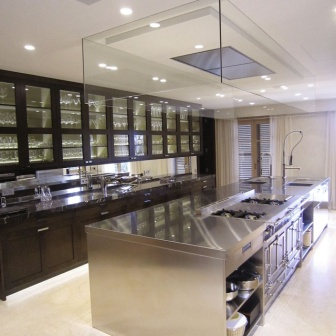Describe more details about the lighting setup in this kitchen. The lighting in this kitchen is both functional and ornamental. Ceiling-mounted rectangular fixtures distribute light evenly across the room, eliminating shadows and enhancing visibility. Each cabinet features built-in lights that not only illuminate the interiors but also create a warm ambiance by casting a gentle glow on the dark wood. The reflective surfaces, like the gleaming stainless steel countertop and the glass cabinet doors, amplify the light further, ensuring every corner is well-lit. The overall effect is a bright, inviting, and well-balanced space perfectly designed for both everyday cooking and social gatherings. How does the natural light complement the artificial lights? The natural light entering through the large window complements the artificial lights beautifully. During the day, sunlight streams through, enhancing the room’s brightness and creating a lively atmosphere. The white blinds diffuse the light, ensuring it’s soft and even, reducing the need for artificial lighting during sunny periods. The combination of natural and artificial lighting brings out the warm tones of the dark wood cabinets and the smooth finish of the stainless steel countertops, creating a harmonious and balanced light-scape that adapts to different times of the day. 